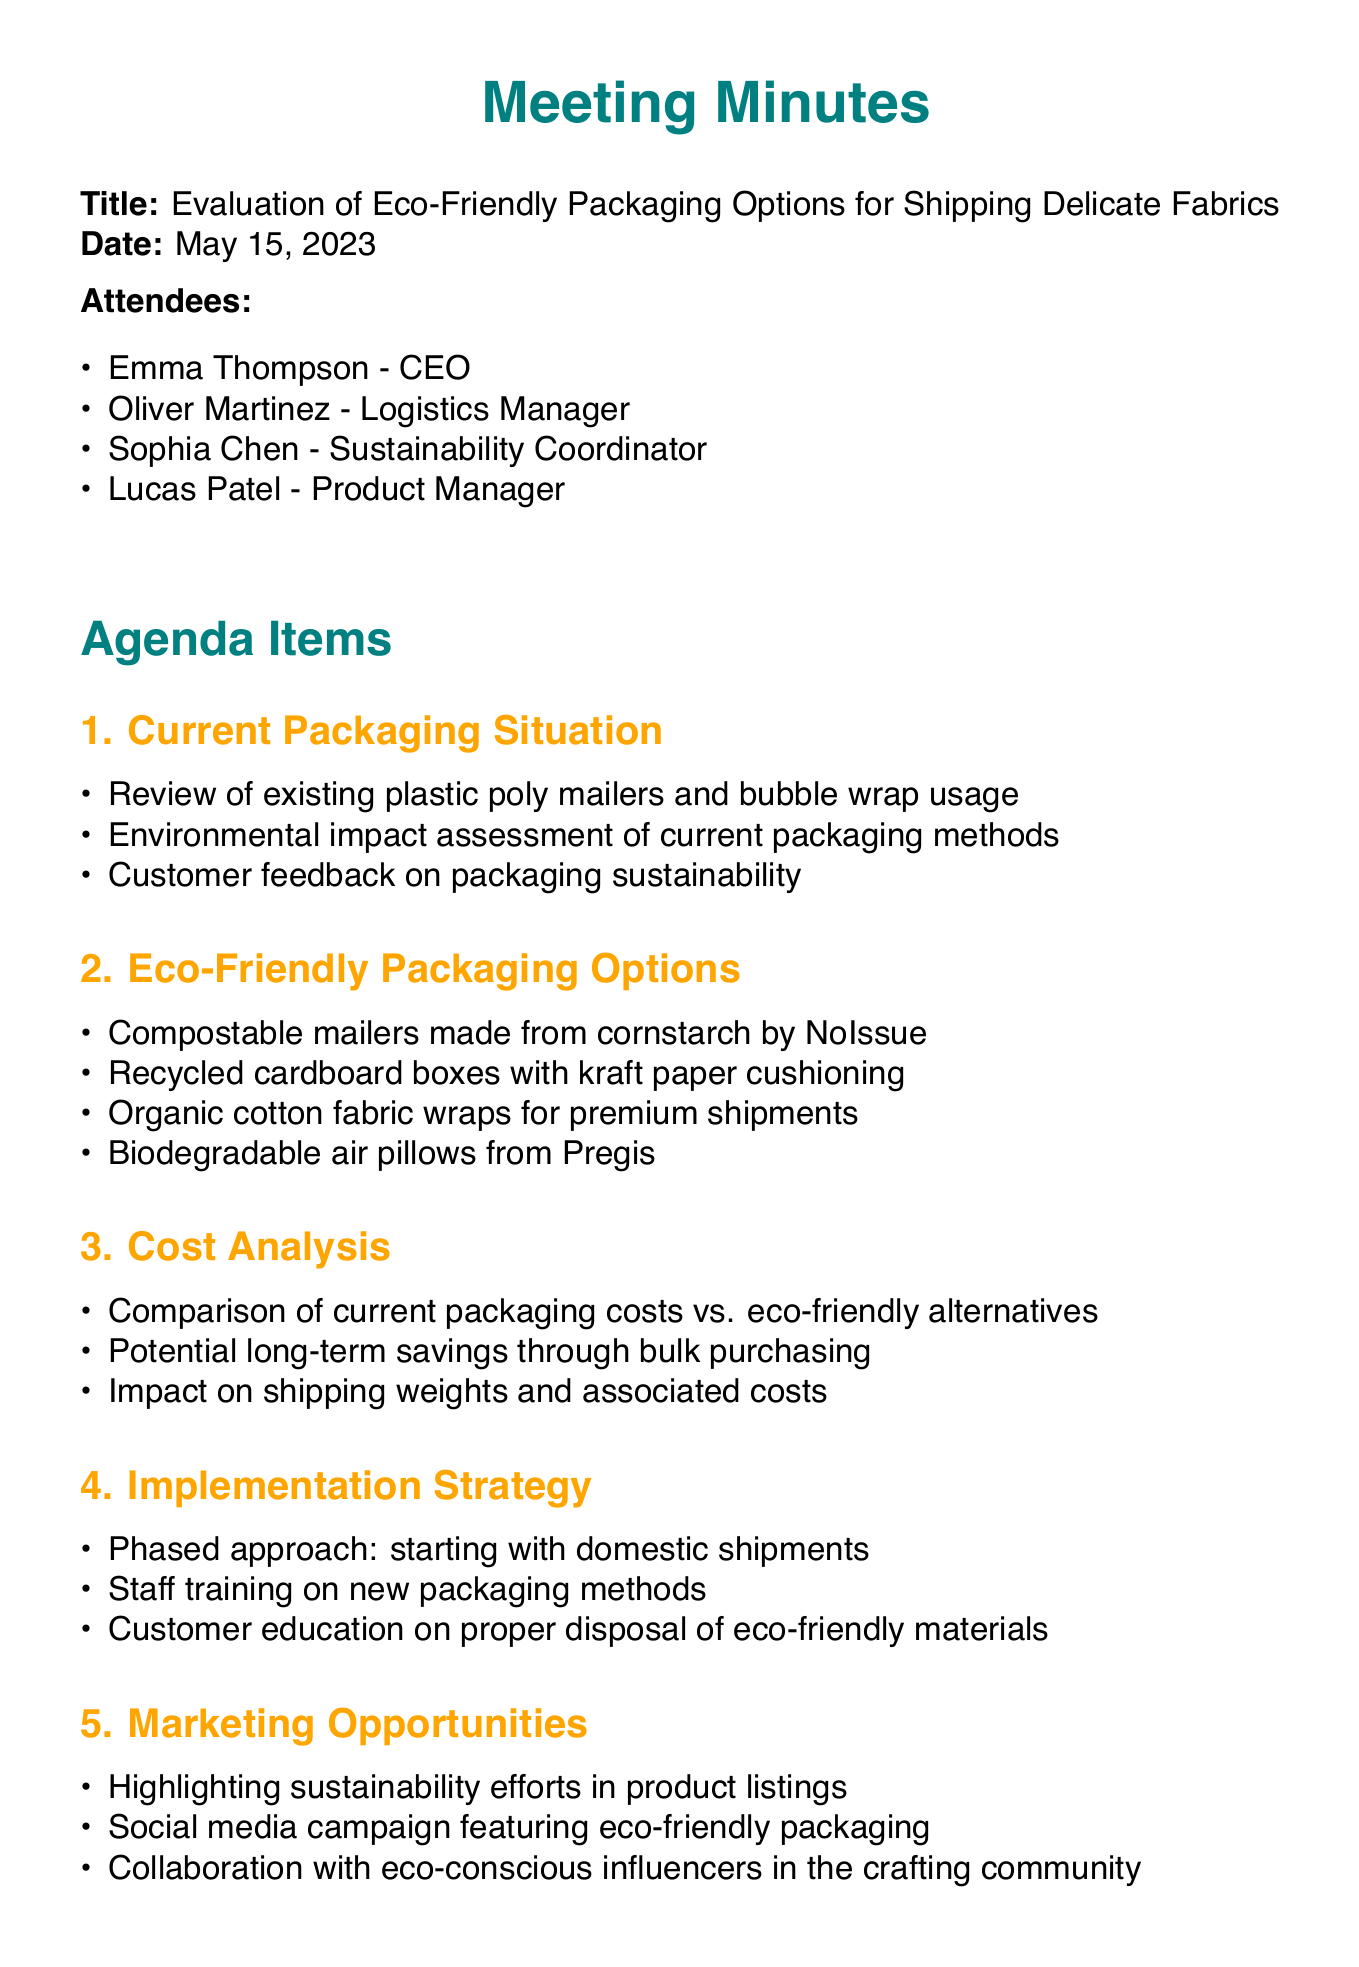What is the title of the meeting? The title of the meeting is stated at the beginning of the document.
Answer: Evaluation of Eco-Friendly Packaging Options for Shipping Delicate Fabrics Who is the Sustainability Coordinator? The document lists the attendees and their roles, identifying Sophia Chen as the Sustainability Coordinator.
Answer: Sophia Chen What date is the next meeting scheduled for? The next meeting date is explicitly mentioned at the end of the document.
Answer: May 29, 2023 What options are discussed for eco-friendly packaging? The document enumerates specific eco-friendly packaging options under the relevant agenda item.
Answer: Compostable mailers, Recycled cardboard boxes, Organic cotton fabric wraps, Biodegradable air pillows How many attendees were present at the meeting? The document lists the attendees in a bullet-point format, allowing us to count them directly.
Answer: Four Which item is Oliver responsible for in the action items? The action items specify each person's responsibilities, showing what Oliver is tasked with.
Answer: Request samples from NoIssue and Pregis for testing What is the main focus of the cost analysis agenda item? The document outlines specific discussion points under the cost analysis agenda item, focusing on costs.
Answer: Comparison of current packaging costs vs. eco-friendly alternatives What was the approach suggested for implementation? The implementation strategy explicitly mentioned the phased approach for rolling out the new packaging.
Answer: Phased approach: starting with domestic shipments 